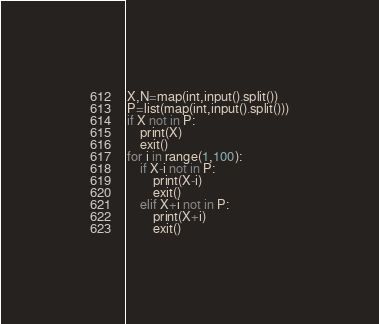Convert code to text. <code><loc_0><loc_0><loc_500><loc_500><_Python_>X,N=map(int,input().split())
P=list(map(int,input().split()))
if X not in P:
    print(X)
    exit()
for i in range(1,100):
    if X-i not in P:
        print(X-i)
        exit()
    elif X+i not in P:
        print(X+i)
        exit()</code> 